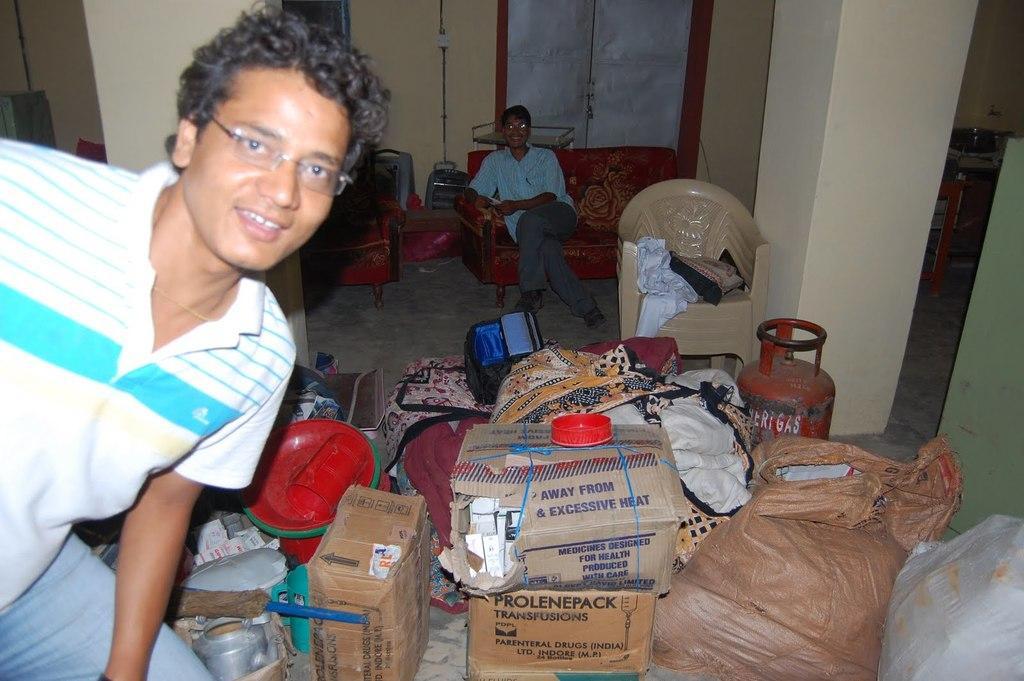Describe this image in one or two sentences. On the left side of the image we can see a person. In the center of the image there is a cylinder, chairs, bag, clothes, objects and kettle. In the background there is a person sitting on the sofa, door, wall, switch board and a window. 